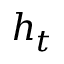Convert formula to latex. <formula><loc_0><loc_0><loc_500><loc_500>h _ { t }</formula> 